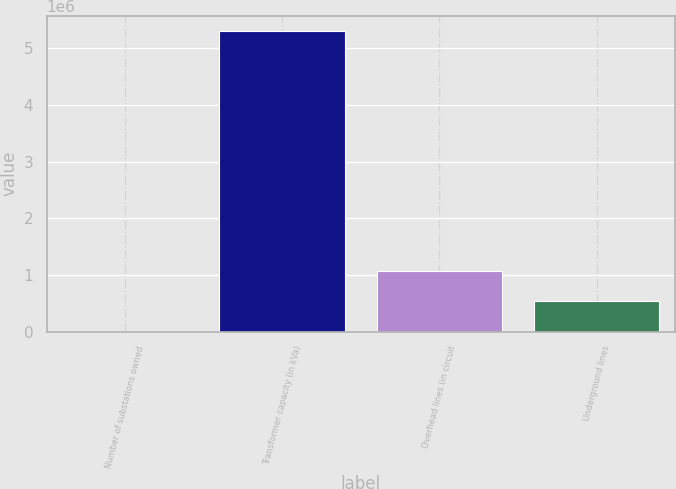<chart> <loc_0><loc_0><loc_500><loc_500><bar_chart><fcel>Number of substations owned<fcel>Transformer capacity (in kVa)<fcel>Overhead lines (in circuit<fcel>Underground lines<nl><fcel>148<fcel>5.31e+06<fcel>1.06212e+06<fcel>531133<nl></chart> 